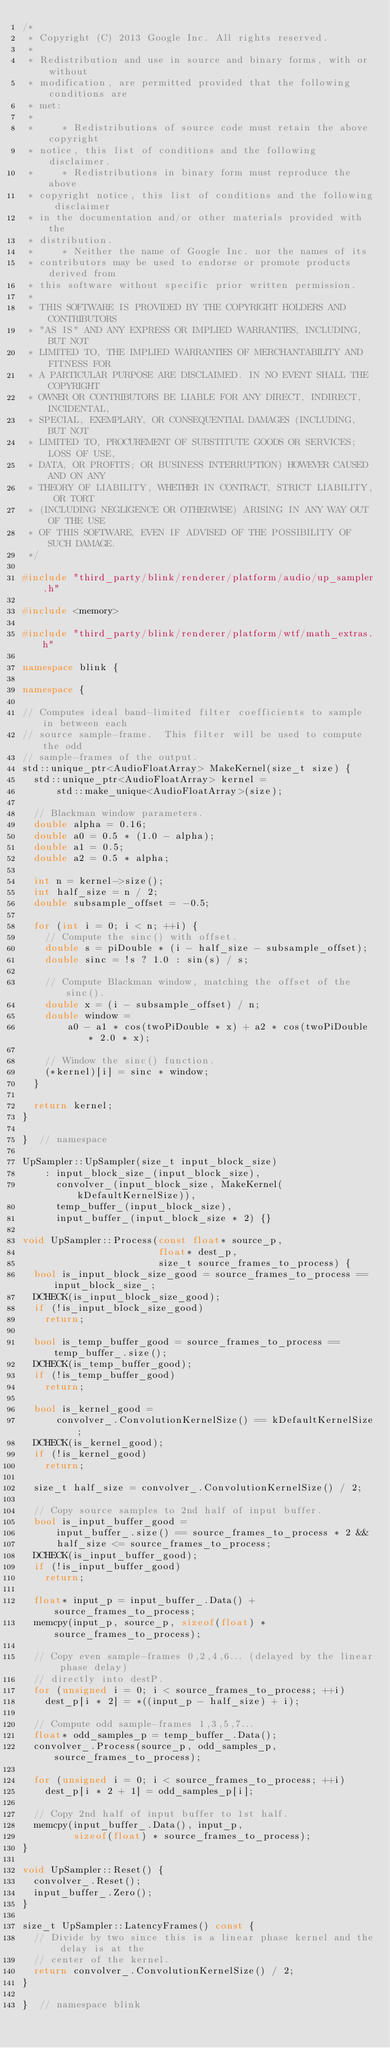<code> <loc_0><loc_0><loc_500><loc_500><_C++_>/*
 * Copyright (C) 2013 Google Inc. All rights reserved.
 *
 * Redistribution and use in source and binary forms, with or without
 * modification, are permitted provided that the following conditions are
 * met:
 *
 *     * Redistributions of source code must retain the above copyright
 * notice, this list of conditions and the following disclaimer.
 *     * Redistributions in binary form must reproduce the above
 * copyright notice, this list of conditions and the following disclaimer
 * in the documentation and/or other materials provided with the
 * distribution.
 *     * Neither the name of Google Inc. nor the names of its
 * contributors may be used to endorse or promote products derived from
 * this software without specific prior written permission.
 *
 * THIS SOFTWARE IS PROVIDED BY THE COPYRIGHT HOLDERS AND CONTRIBUTORS
 * "AS IS" AND ANY EXPRESS OR IMPLIED WARRANTIES, INCLUDING, BUT NOT
 * LIMITED TO, THE IMPLIED WARRANTIES OF MERCHANTABILITY AND FITNESS FOR
 * A PARTICULAR PURPOSE ARE DISCLAIMED. IN NO EVENT SHALL THE COPYRIGHT
 * OWNER OR CONTRIBUTORS BE LIABLE FOR ANY DIRECT, INDIRECT, INCIDENTAL,
 * SPECIAL, EXEMPLARY, OR CONSEQUENTIAL DAMAGES (INCLUDING, BUT NOT
 * LIMITED TO, PROCUREMENT OF SUBSTITUTE GOODS OR SERVICES; LOSS OF USE,
 * DATA, OR PROFITS; OR BUSINESS INTERRUPTION) HOWEVER CAUSED AND ON ANY
 * THEORY OF LIABILITY, WHETHER IN CONTRACT, STRICT LIABILITY, OR TORT
 * (INCLUDING NEGLIGENCE OR OTHERWISE) ARISING IN ANY WAY OUT OF THE USE
 * OF THIS SOFTWARE, EVEN IF ADVISED OF THE POSSIBILITY OF SUCH DAMAGE.
 */

#include "third_party/blink/renderer/platform/audio/up_sampler.h"

#include <memory>

#include "third_party/blink/renderer/platform/wtf/math_extras.h"

namespace blink {

namespace {

// Computes ideal band-limited filter coefficients to sample in between each
// source sample-frame.  This filter will be used to compute the odd
// sample-frames of the output.
std::unique_ptr<AudioFloatArray> MakeKernel(size_t size) {
  std::unique_ptr<AudioFloatArray> kernel =
      std::make_unique<AudioFloatArray>(size);

  // Blackman window parameters.
  double alpha = 0.16;
  double a0 = 0.5 * (1.0 - alpha);
  double a1 = 0.5;
  double a2 = 0.5 * alpha;

  int n = kernel->size();
  int half_size = n / 2;
  double subsample_offset = -0.5;

  for (int i = 0; i < n; ++i) {
    // Compute the sinc() with offset.
    double s = piDouble * (i - half_size - subsample_offset);
    double sinc = !s ? 1.0 : sin(s) / s;

    // Compute Blackman window, matching the offset of the sinc().
    double x = (i - subsample_offset) / n;
    double window =
        a0 - a1 * cos(twoPiDouble * x) + a2 * cos(twoPiDouble * 2.0 * x);

    // Window the sinc() function.
    (*kernel)[i] = sinc * window;
  }

  return kernel;
}

}  // namespace

UpSampler::UpSampler(size_t input_block_size)
    : input_block_size_(input_block_size),
      convolver_(input_block_size, MakeKernel(kDefaultKernelSize)),
      temp_buffer_(input_block_size),
      input_buffer_(input_block_size * 2) {}

void UpSampler::Process(const float* source_p,
                        float* dest_p,
                        size_t source_frames_to_process) {
  bool is_input_block_size_good = source_frames_to_process == input_block_size_;
  DCHECK(is_input_block_size_good);
  if (!is_input_block_size_good)
    return;

  bool is_temp_buffer_good = source_frames_to_process == temp_buffer_.size();
  DCHECK(is_temp_buffer_good);
  if (!is_temp_buffer_good)
    return;

  bool is_kernel_good =
      convolver_.ConvolutionKernelSize() == kDefaultKernelSize;
  DCHECK(is_kernel_good);
  if (!is_kernel_good)
    return;

  size_t half_size = convolver_.ConvolutionKernelSize() / 2;

  // Copy source samples to 2nd half of input buffer.
  bool is_input_buffer_good =
      input_buffer_.size() == source_frames_to_process * 2 &&
      half_size <= source_frames_to_process;
  DCHECK(is_input_buffer_good);
  if (!is_input_buffer_good)
    return;

  float* input_p = input_buffer_.Data() + source_frames_to_process;
  memcpy(input_p, source_p, sizeof(float) * source_frames_to_process);

  // Copy even sample-frames 0,2,4,6... (delayed by the linear phase delay)
  // directly into destP.
  for (unsigned i = 0; i < source_frames_to_process; ++i)
    dest_p[i * 2] = *((input_p - half_size) + i);

  // Compute odd sample-frames 1,3,5,7...
  float* odd_samples_p = temp_buffer_.Data();
  convolver_.Process(source_p, odd_samples_p, source_frames_to_process);

  for (unsigned i = 0; i < source_frames_to_process; ++i)
    dest_p[i * 2 + 1] = odd_samples_p[i];

  // Copy 2nd half of input buffer to 1st half.
  memcpy(input_buffer_.Data(), input_p,
         sizeof(float) * source_frames_to_process);
}

void UpSampler::Reset() {
  convolver_.Reset();
  input_buffer_.Zero();
}

size_t UpSampler::LatencyFrames() const {
  // Divide by two since this is a linear phase kernel and the delay is at the
  // center of the kernel.
  return convolver_.ConvolutionKernelSize() / 2;
}

}  // namespace blink
</code> 